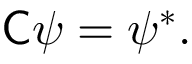Convert formula to latex. <formula><loc_0><loc_0><loc_500><loc_500>{ C } \psi = \psi ^ { * } .</formula> 